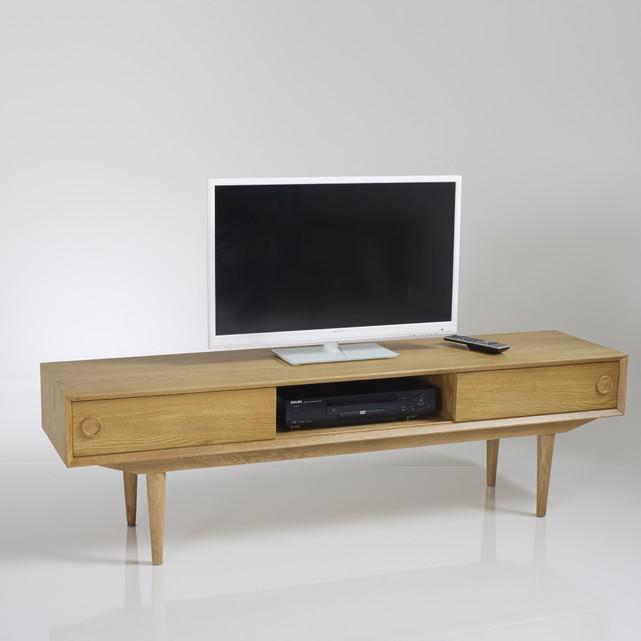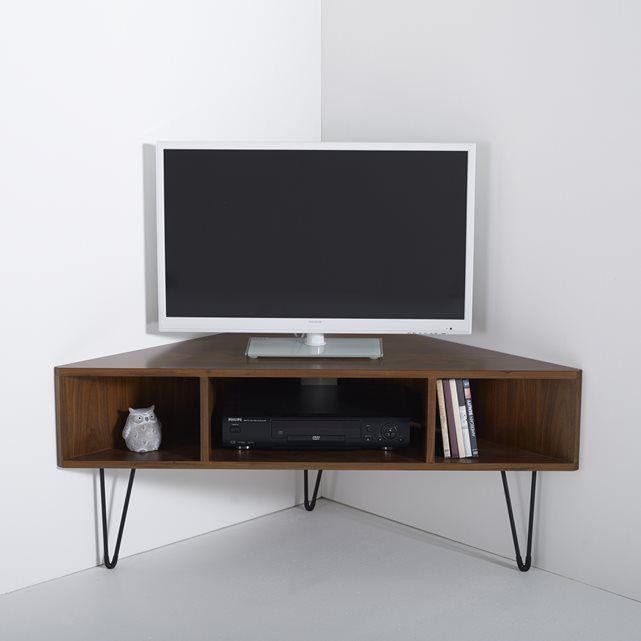The first image is the image on the left, the second image is the image on the right. Assess this claim about the two images: "Both TVs have black frames.". Correct or not? Answer yes or no. No. The first image is the image on the left, the second image is the image on the right. Considering the images on both sides, is "The legs of one media stand is made of metal." valid? Answer yes or no. Yes. 